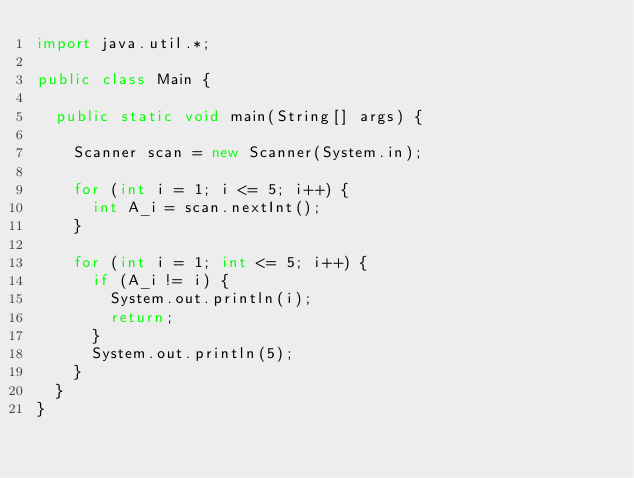Convert code to text. <code><loc_0><loc_0><loc_500><loc_500><_Java_>import java.util.*;

public class Main {
  
  public static void main(String[] args) {
    
    Scanner scan = new Scanner(System.in);
    
    for (int i = 1; i <= 5; i++) {
      int A_i = scan.nextInt();
    }
    
    for (int i = 1; int <= 5; i++) {
      if (A_i != i) {
        System.out.println(i);
        return;
      }
      System.out.println(5);
    }
  }
}</code> 